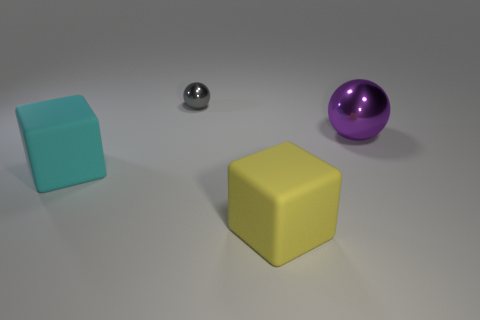There is a large rubber thing that is in front of the large rubber block behind the rubber block on the right side of the large cyan object; what is its shape?
Your answer should be very brief. Cube. Is the tiny object the same shape as the yellow matte object?
Offer a terse response. No. There is a rubber thing that is to the left of the shiny ball that is left of the big purple metallic ball; what is its shape?
Make the answer very short. Cube. Is there a large shiny object?
Your answer should be very brief. Yes. There is a metal sphere that is to the left of the big block to the right of the small ball; how many purple shiny objects are right of it?
Ensure brevity in your answer.  1. Does the small shiny object have the same shape as the large matte object that is to the right of the tiny gray ball?
Offer a terse response. No. Is the number of yellow things greater than the number of big green matte blocks?
Provide a succinct answer. Yes. Is there any other thing that has the same size as the gray sphere?
Your answer should be very brief. No. Does the thing on the left side of the small gray shiny sphere have the same shape as the purple metallic thing?
Keep it short and to the point. No. Are there more large things that are on the left side of the purple object than large cyan matte objects?
Offer a terse response. Yes. 